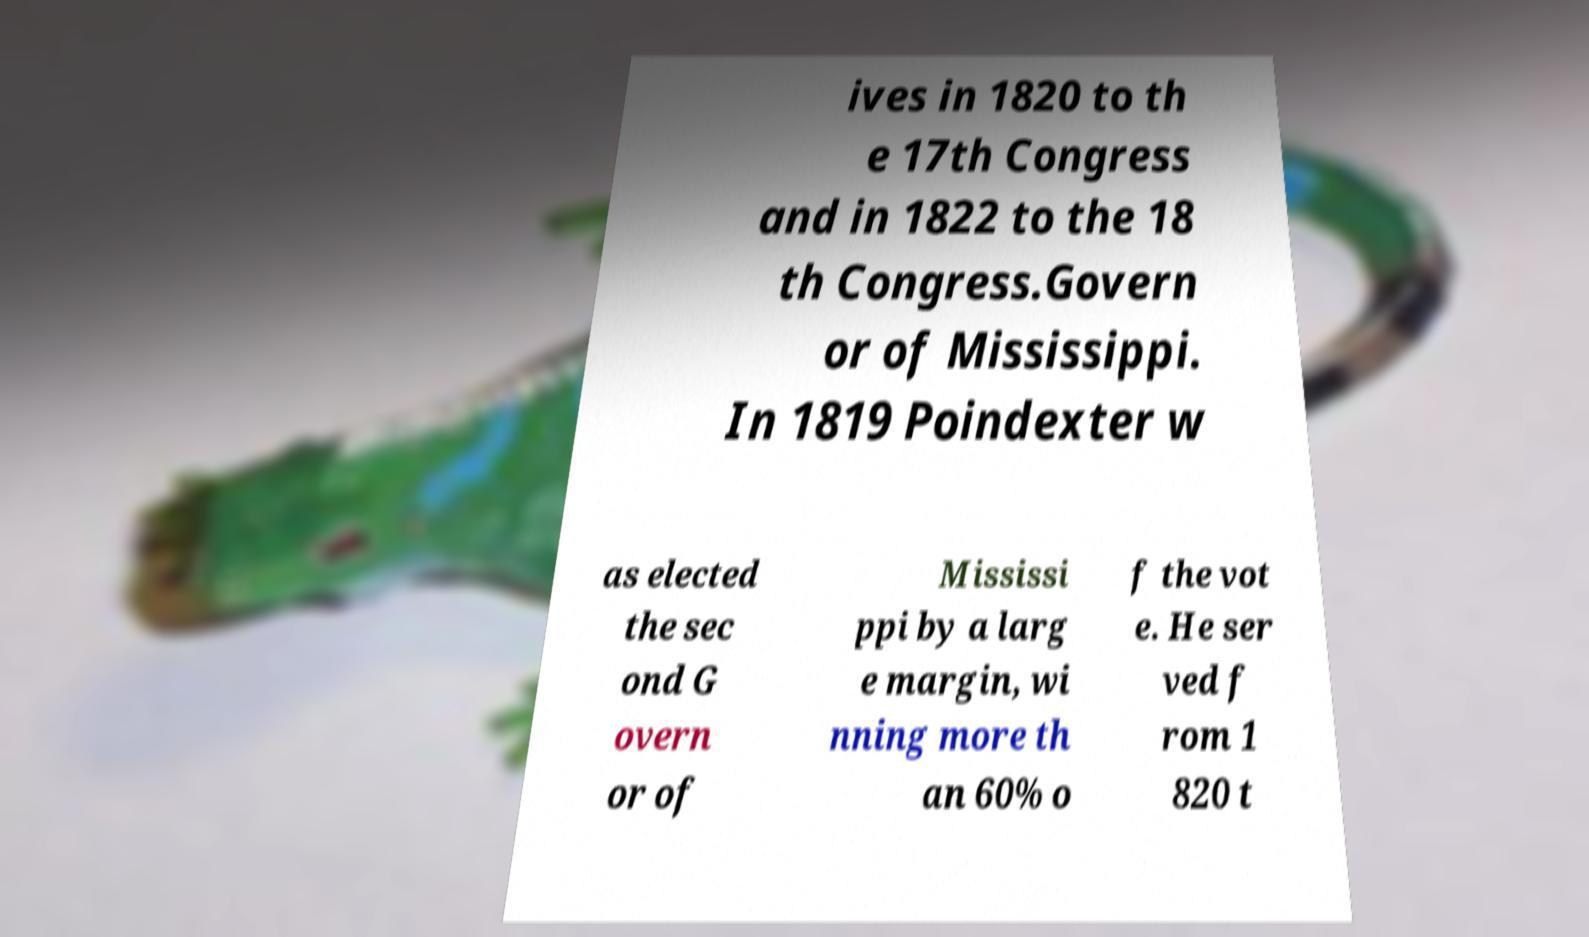There's text embedded in this image that I need extracted. Can you transcribe it verbatim? ives in 1820 to th e 17th Congress and in 1822 to the 18 th Congress.Govern or of Mississippi. In 1819 Poindexter w as elected the sec ond G overn or of Mississi ppi by a larg e margin, wi nning more th an 60% o f the vot e. He ser ved f rom 1 820 t 